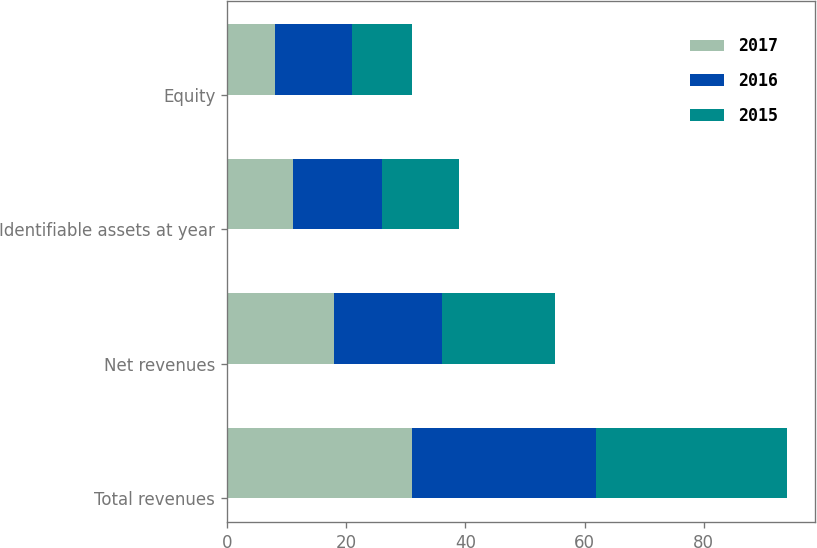<chart> <loc_0><loc_0><loc_500><loc_500><stacked_bar_chart><ecel><fcel>Total revenues<fcel>Net revenues<fcel>Identifiable assets at year<fcel>Equity<nl><fcel>2017<fcel>31<fcel>18<fcel>11<fcel>8<nl><fcel>2016<fcel>31<fcel>18<fcel>15<fcel>13<nl><fcel>2015<fcel>32<fcel>19<fcel>13<fcel>10<nl></chart> 